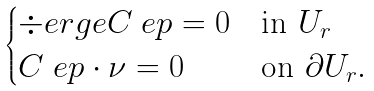Convert formula to latex. <formula><loc_0><loc_0><loc_500><loc_500>\begin{cases} \div e r g e { C _ { \ } e p } = 0 & \text {in } U _ { r } \\ C _ { \ } e p \cdot \nu = 0 & \text {on } \partial U _ { r } . \end{cases}</formula> 